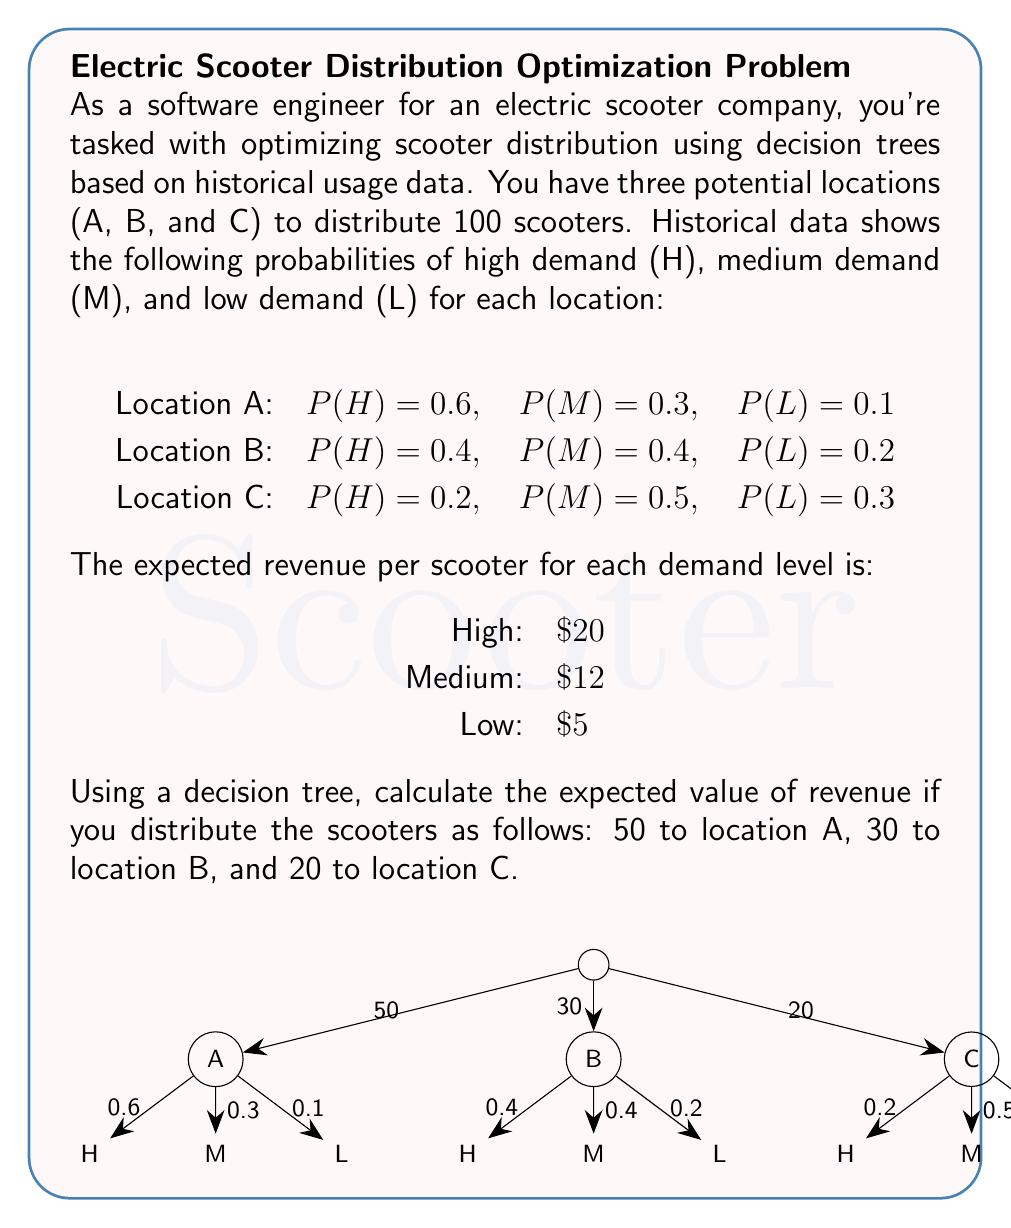Could you help me with this problem? Let's calculate the expected value for each location separately and then sum them up:

1. Location A (50 scooters):
   Expected Value = $50 \times (0.6 \times 20 + 0.3 \times 12 + 0.1 \times 5)$
   $= 50 \times (12 + 3.6 + 0.5) = 50 \times 16.1 = 805$

2. Location B (30 scooters):
   Expected Value = $30 \times (0.4 \times 20 + 0.4 \times 12 + 0.2 \times 5)$
   $= 30 \times (8 + 4.8 + 1) = 30 \times 13.8 = 414$

3. Location C (20 scooters):
   Expected Value = $20 \times (0.2 \times 20 + 0.5 \times 12 + 0.3 \times 5)$
   $= 20 \times (4 + 6 + 1.5) = 20 \times 11.5 = 230$

Total Expected Value = $805 + 414 + 230 = 1449$

Therefore, the expected value of revenue for this distribution is $1449.
Answer: $1449 